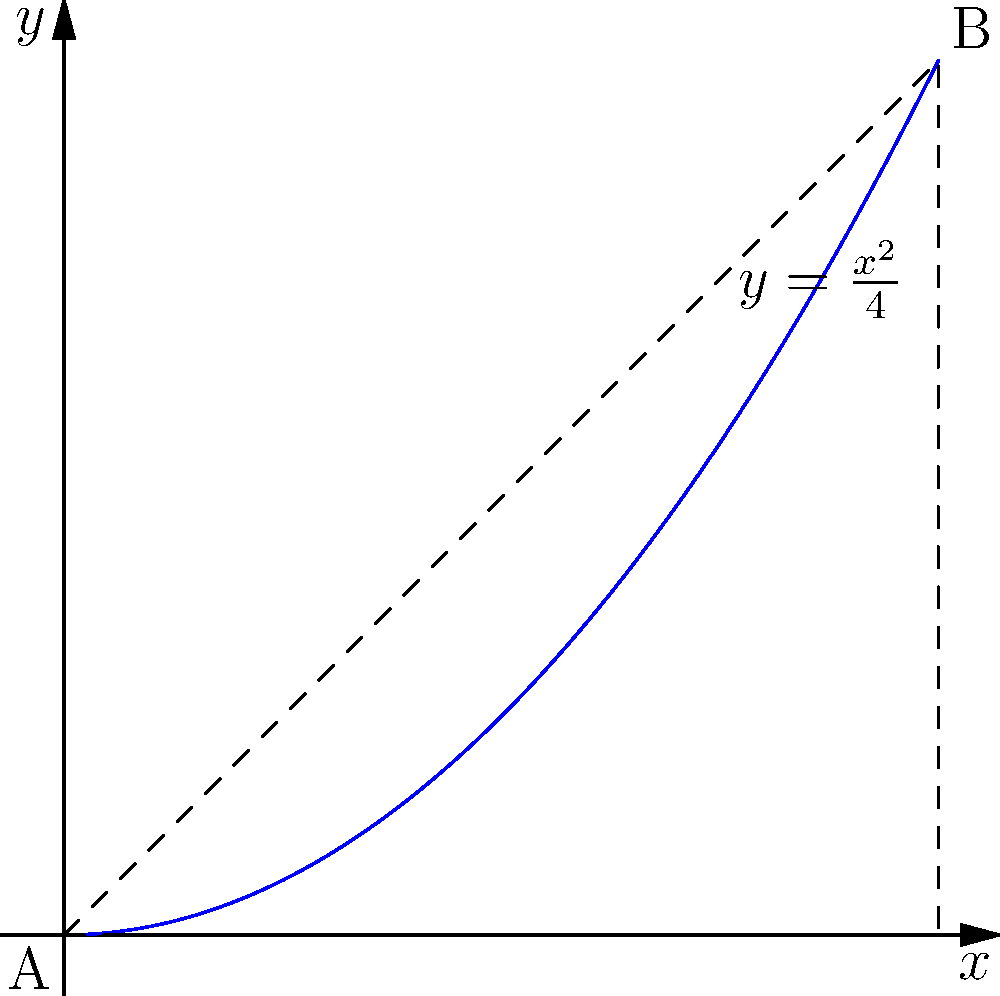As a parent helping your child with homework, you encounter a problem about the area under a curved line. The curve is given by the equation $y=\frac{x^2}{4}$ from $x=0$ to $x=4$. What is the area of the region bounded by this curve and the x-axis? Let's approach this step-by-step:

1) The area under a curve is given by the definite integral from the lower bound to the upper bound.

2) In this case, we need to integrate $y=\frac{x^2}{4}$ from $x=0$ to $x=4$.

3) The integral is:

   $$\int_0^4 \frac{x^2}{4} dx$$

4) To solve this, let's integrate:
   
   $$\int \frac{x^2}{4} dx = \frac{1}{4} \cdot \frac{x^3}{3} + C = \frac{x^3}{12} + C$$

5) Now, we need to evaluate this from 0 to 4:

   $$[\frac{x^3}{12}]_0^4 = \frac{4^3}{12} - \frac{0^3}{12} = \frac{64}{12} - 0 = \frac{16}{3}$$

6) Therefore, the area under the curve is $\frac{16}{3}$ square units.
Answer: $\frac{16}{3}$ square units 